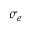<formula> <loc_0><loc_0><loc_500><loc_500>\sigma _ { e }</formula> 